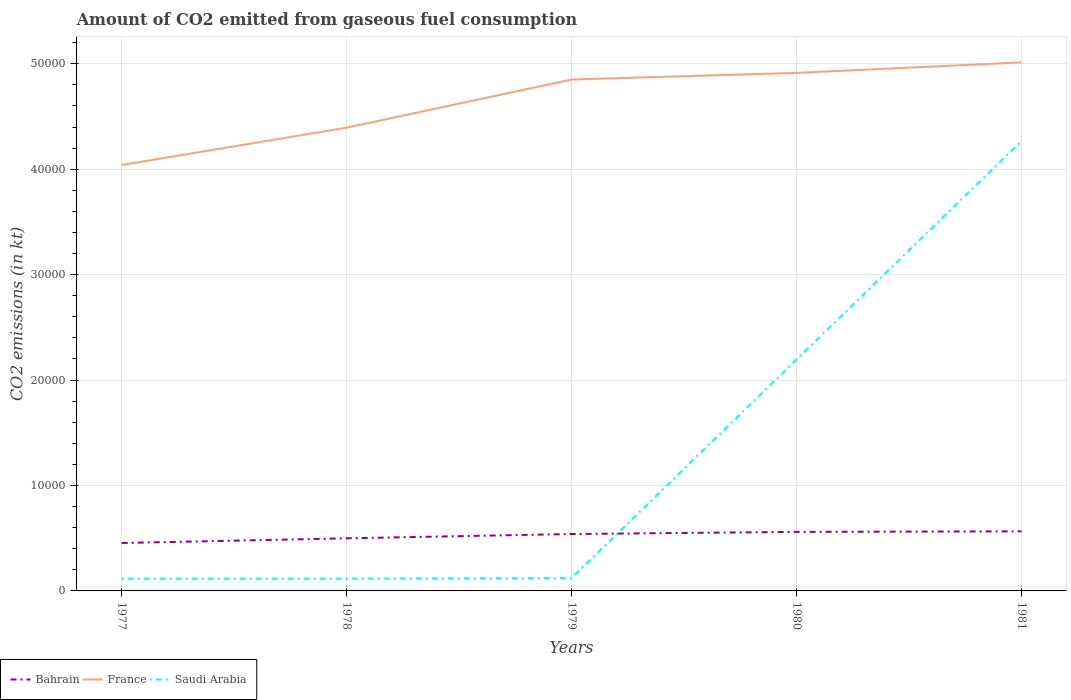How many different coloured lines are there?
Your answer should be compact. 3. Across all years, what is the maximum amount of CO2 emitted in Saudi Arabia?
Your response must be concise. 1162.44. What is the total amount of CO2 emitted in Saudi Arabia in the graph?
Keep it short and to the point. -2.07e+04. What is the difference between the highest and the second highest amount of CO2 emitted in Bahrain?
Your answer should be very brief. 1107.43. What is the difference between the highest and the lowest amount of CO2 emitted in Saudi Arabia?
Your answer should be compact. 2. Is the amount of CO2 emitted in Saudi Arabia strictly greater than the amount of CO2 emitted in France over the years?
Offer a terse response. Yes. How many lines are there?
Ensure brevity in your answer.  3. What is the difference between two consecutive major ticks on the Y-axis?
Keep it short and to the point. 10000. Are the values on the major ticks of Y-axis written in scientific E-notation?
Provide a succinct answer. No. Does the graph contain any zero values?
Offer a terse response. No. What is the title of the graph?
Provide a succinct answer. Amount of CO2 emitted from gaseous fuel consumption. What is the label or title of the X-axis?
Offer a terse response. Years. What is the label or title of the Y-axis?
Ensure brevity in your answer.  CO2 emissions (in kt). What is the CO2 emissions (in kt) in Bahrain in 1977?
Offer a terse response. 4543.41. What is the CO2 emissions (in kt) of France in 1977?
Provide a succinct answer. 4.04e+04. What is the CO2 emissions (in kt) in Saudi Arabia in 1977?
Offer a very short reply. 1162.44. What is the CO2 emissions (in kt) in Bahrain in 1978?
Keep it short and to the point. 4990.79. What is the CO2 emissions (in kt) of France in 1978?
Your answer should be compact. 4.39e+04. What is the CO2 emissions (in kt) of Saudi Arabia in 1978?
Make the answer very short. 1162.44. What is the CO2 emissions (in kt) in Bahrain in 1979?
Make the answer very short. 5397.82. What is the CO2 emissions (in kt) of France in 1979?
Offer a very short reply. 4.85e+04. What is the CO2 emissions (in kt) in Saudi Arabia in 1979?
Your answer should be very brief. 1232.11. What is the CO2 emissions (in kt) of Bahrain in 1980?
Keep it short and to the point. 5599.51. What is the CO2 emissions (in kt) of France in 1980?
Provide a short and direct response. 4.91e+04. What is the CO2 emissions (in kt) in Saudi Arabia in 1980?
Your answer should be compact. 2.20e+04. What is the CO2 emissions (in kt) in Bahrain in 1981?
Provide a succinct answer. 5650.85. What is the CO2 emissions (in kt) in France in 1981?
Provide a short and direct response. 5.01e+04. What is the CO2 emissions (in kt) of Saudi Arabia in 1981?
Provide a short and direct response. 4.27e+04. Across all years, what is the maximum CO2 emissions (in kt) of Bahrain?
Your answer should be compact. 5650.85. Across all years, what is the maximum CO2 emissions (in kt) of France?
Provide a short and direct response. 5.01e+04. Across all years, what is the maximum CO2 emissions (in kt) in Saudi Arabia?
Provide a short and direct response. 4.27e+04. Across all years, what is the minimum CO2 emissions (in kt) of Bahrain?
Offer a very short reply. 4543.41. Across all years, what is the minimum CO2 emissions (in kt) in France?
Your answer should be very brief. 4.04e+04. Across all years, what is the minimum CO2 emissions (in kt) of Saudi Arabia?
Keep it short and to the point. 1162.44. What is the total CO2 emissions (in kt) of Bahrain in the graph?
Make the answer very short. 2.62e+04. What is the total CO2 emissions (in kt) in France in the graph?
Your response must be concise. 2.32e+05. What is the total CO2 emissions (in kt) of Saudi Arabia in the graph?
Ensure brevity in your answer.  6.82e+04. What is the difference between the CO2 emissions (in kt) of Bahrain in 1977 and that in 1978?
Provide a succinct answer. -447.37. What is the difference between the CO2 emissions (in kt) of France in 1977 and that in 1978?
Offer a very short reply. -3545.99. What is the difference between the CO2 emissions (in kt) in Saudi Arabia in 1977 and that in 1978?
Keep it short and to the point. 0. What is the difference between the CO2 emissions (in kt) of Bahrain in 1977 and that in 1979?
Provide a short and direct response. -854.41. What is the difference between the CO2 emissions (in kt) in France in 1977 and that in 1979?
Keep it short and to the point. -8107.74. What is the difference between the CO2 emissions (in kt) of Saudi Arabia in 1977 and that in 1979?
Make the answer very short. -69.67. What is the difference between the CO2 emissions (in kt) in Bahrain in 1977 and that in 1980?
Your response must be concise. -1056.1. What is the difference between the CO2 emissions (in kt) of France in 1977 and that in 1980?
Provide a succinct answer. -8738.46. What is the difference between the CO2 emissions (in kt) of Saudi Arabia in 1977 and that in 1980?
Your response must be concise. -2.08e+04. What is the difference between the CO2 emissions (in kt) in Bahrain in 1977 and that in 1981?
Your answer should be very brief. -1107.43. What is the difference between the CO2 emissions (in kt) in France in 1977 and that in 1981?
Provide a short and direct response. -9732.22. What is the difference between the CO2 emissions (in kt) in Saudi Arabia in 1977 and that in 1981?
Offer a very short reply. -4.15e+04. What is the difference between the CO2 emissions (in kt) of Bahrain in 1978 and that in 1979?
Your answer should be compact. -407.04. What is the difference between the CO2 emissions (in kt) in France in 1978 and that in 1979?
Provide a succinct answer. -4561.75. What is the difference between the CO2 emissions (in kt) of Saudi Arabia in 1978 and that in 1979?
Make the answer very short. -69.67. What is the difference between the CO2 emissions (in kt) in Bahrain in 1978 and that in 1980?
Offer a terse response. -608.72. What is the difference between the CO2 emissions (in kt) in France in 1978 and that in 1980?
Your response must be concise. -5192.47. What is the difference between the CO2 emissions (in kt) in Saudi Arabia in 1978 and that in 1980?
Offer a very short reply. -2.08e+04. What is the difference between the CO2 emissions (in kt) in Bahrain in 1978 and that in 1981?
Ensure brevity in your answer.  -660.06. What is the difference between the CO2 emissions (in kt) in France in 1978 and that in 1981?
Make the answer very short. -6186.23. What is the difference between the CO2 emissions (in kt) in Saudi Arabia in 1978 and that in 1981?
Give a very brief answer. -4.15e+04. What is the difference between the CO2 emissions (in kt) of Bahrain in 1979 and that in 1980?
Ensure brevity in your answer.  -201.69. What is the difference between the CO2 emissions (in kt) in France in 1979 and that in 1980?
Provide a succinct answer. -630.72. What is the difference between the CO2 emissions (in kt) of Saudi Arabia in 1979 and that in 1980?
Give a very brief answer. -2.07e+04. What is the difference between the CO2 emissions (in kt) of Bahrain in 1979 and that in 1981?
Provide a short and direct response. -253.02. What is the difference between the CO2 emissions (in kt) in France in 1979 and that in 1981?
Make the answer very short. -1624.48. What is the difference between the CO2 emissions (in kt) of Saudi Arabia in 1979 and that in 1981?
Give a very brief answer. -4.15e+04. What is the difference between the CO2 emissions (in kt) of Bahrain in 1980 and that in 1981?
Your response must be concise. -51.34. What is the difference between the CO2 emissions (in kt) of France in 1980 and that in 1981?
Keep it short and to the point. -993.76. What is the difference between the CO2 emissions (in kt) in Saudi Arabia in 1980 and that in 1981?
Offer a terse response. -2.07e+04. What is the difference between the CO2 emissions (in kt) in Bahrain in 1977 and the CO2 emissions (in kt) in France in 1978?
Keep it short and to the point. -3.94e+04. What is the difference between the CO2 emissions (in kt) of Bahrain in 1977 and the CO2 emissions (in kt) of Saudi Arabia in 1978?
Provide a short and direct response. 3380.97. What is the difference between the CO2 emissions (in kt) in France in 1977 and the CO2 emissions (in kt) in Saudi Arabia in 1978?
Provide a succinct answer. 3.92e+04. What is the difference between the CO2 emissions (in kt) of Bahrain in 1977 and the CO2 emissions (in kt) of France in 1979?
Offer a very short reply. -4.40e+04. What is the difference between the CO2 emissions (in kt) in Bahrain in 1977 and the CO2 emissions (in kt) in Saudi Arabia in 1979?
Offer a very short reply. 3311.3. What is the difference between the CO2 emissions (in kt) in France in 1977 and the CO2 emissions (in kt) in Saudi Arabia in 1979?
Your answer should be compact. 3.92e+04. What is the difference between the CO2 emissions (in kt) in Bahrain in 1977 and the CO2 emissions (in kt) in France in 1980?
Ensure brevity in your answer.  -4.46e+04. What is the difference between the CO2 emissions (in kt) of Bahrain in 1977 and the CO2 emissions (in kt) of Saudi Arabia in 1980?
Your answer should be compact. -1.74e+04. What is the difference between the CO2 emissions (in kt) of France in 1977 and the CO2 emissions (in kt) of Saudi Arabia in 1980?
Offer a terse response. 1.84e+04. What is the difference between the CO2 emissions (in kt) of Bahrain in 1977 and the CO2 emissions (in kt) of France in 1981?
Make the answer very short. -4.56e+04. What is the difference between the CO2 emissions (in kt) of Bahrain in 1977 and the CO2 emissions (in kt) of Saudi Arabia in 1981?
Offer a terse response. -3.81e+04. What is the difference between the CO2 emissions (in kt) of France in 1977 and the CO2 emissions (in kt) of Saudi Arabia in 1981?
Provide a succinct answer. -2284.54. What is the difference between the CO2 emissions (in kt) of Bahrain in 1978 and the CO2 emissions (in kt) of France in 1979?
Offer a terse response. -4.35e+04. What is the difference between the CO2 emissions (in kt) of Bahrain in 1978 and the CO2 emissions (in kt) of Saudi Arabia in 1979?
Your answer should be very brief. 3758.68. What is the difference between the CO2 emissions (in kt) in France in 1978 and the CO2 emissions (in kt) in Saudi Arabia in 1979?
Your answer should be very brief. 4.27e+04. What is the difference between the CO2 emissions (in kt) of Bahrain in 1978 and the CO2 emissions (in kt) of France in 1980?
Your response must be concise. -4.41e+04. What is the difference between the CO2 emissions (in kt) of Bahrain in 1978 and the CO2 emissions (in kt) of Saudi Arabia in 1980?
Give a very brief answer. -1.70e+04. What is the difference between the CO2 emissions (in kt) of France in 1978 and the CO2 emissions (in kt) of Saudi Arabia in 1980?
Offer a terse response. 2.20e+04. What is the difference between the CO2 emissions (in kt) in Bahrain in 1978 and the CO2 emissions (in kt) in France in 1981?
Make the answer very short. -4.51e+04. What is the difference between the CO2 emissions (in kt) of Bahrain in 1978 and the CO2 emissions (in kt) of Saudi Arabia in 1981?
Offer a terse response. -3.77e+04. What is the difference between the CO2 emissions (in kt) of France in 1978 and the CO2 emissions (in kt) of Saudi Arabia in 1981?
Keep it short and to the point. 1261.45. What is the difference between the CO2 emissions (in kt) in Bahrain in 1979 and the CO2 emissions (in kt) in France in 1980?
Provide a succinct answer. -4.37e+04. What is the difference between the CO2 emissions (in kt) in Bahrain in 1979 and the CO2 emissions (in kt) in Saudi Arabia in 1980?
Your response must be concise. -1.66e+04. What is the difference between the CO2 emissions (in kt) in France in 1979 and the CO2 emissions (in kt) in Saudi Arabia in 1980?
Keep it short and to the point. 2.65e+04. What is the difference between the CO2 emissions (in kt) of Bahrain in 1979 and the CO2 emissions (in kt) of France in 1981?
Your answer should be very brief. -4.47e+04. What is the difference between the CO2 emissions (in kt) of Bahrain in 1979 and the CO2 emissions (in kt) of Saudi Arabia in 1981?
Keep it short and to the point. -3.73e+04. What is the difference between the CO2 emissions (in kt) in France in 1979 and the CO2 emissions (in kt) in Saudi Arabia in 1981?
Offer a very short reply. 5823.2. What is the difference between the CO2 emissions (in kt) in Bahrain in 1980 and the CO2 emissions (in kt) in France in 1981?
Ensure brevity in your answer.  -4.45e+04. What is the difference between the CO2 emissions (in kt) in Bahrain in 1980 and the CO2 emissions (in kt) in Saudi Arabia in 1981?
Provide a short and direct response. -3.71e+04. What is the difference between the CO2 emissions (in kt) in France in 1980 and the CO2 emissions (in kt) in Saudi Arabia in 1981?
Ensure brevity in your answer.  6453.92. What is the average CO2 emissions (in kt) of Bahrain per year?
Your answer should be very brief. 5236.48. What is the average CO2 emissions (in kt) of France per year?
Keep it short and to the point. 4.64e+04. What is the average CO2 emissions (in kt) in Saudi Arabia per year?
Keep it short and to the point. 1.36e+04. In the year 1977, what is the difference between the CO2 emissions (in kt) of Bahrain and CO2 emissions (in kt) of France?
Provide a short and direct response. -3.59e+04. In the year 1977, what is the difference between the CO2 emissions (in kt) of Bahrain and CO2 emissions (in kt) of Saudi Arabia?
Offer a very short reply. 3380.97. In the year 1977, what is the difference between the CO2 emissions (in kt) in France and CO2 emissions (in kt) in Saudi Arabia?
Your answer should be very brief. 3.92e+04. In the year 1978, what is the difference between the CO2 emissions (in kt) in Bahrain and CO2 emissions (in kt) in France?
Keep it short and to the point. -3.90e+04. In the year 1978, what is the difference between the CO2 emissions (in kt) in Bahrain and CO2 emissions (in kt) in Saudi Arabia?
Your answer should be very brief. 3828.35. In the year 1978, what is the difference between the CO2 emissions (in kt) in France and CO2 emissions (in kt) in Saudi Arabia?
Your answer should be very brief. 4.28e+04. In the year 1979, what is the difference between the CO2 emissions (in kt) of Bahrain and CO2 emissions (in kt) of France?
Your answer should be compact. -4.31e+04. In the year 1979, what is the difference between the CO2 emissions (in kt) of Bahrain and CO2 emissions (in kt) of Saudi Arabia?
Provide a short and direct response. 4165.71. In the year 1979, what is the difference between the CO2 emissions (in kt) in France and CO2 emissions (in kt) in Saudi Arabia?
Your response must be concise. 4.73e+04. In the year 1980, what is the difference between the CO2 emissions (in kt) of Bahrain and CO2 emissions (in kt) of France?
Give a very brief answer. -4.35e+04. In the year 1980, what is the difference between the CO2 emissions (in kt) of Bahrain and CO2 emissions (in kt) of Saudi Arabia?
Keep it short and to the point. -1.64e+04. In the year 1980, what is the difference between the CO2 emissions (in kt) in France and CO2 emissions (in kt) in Saudi Arabia?
Keep it short and to the point. 2.72e+04. In the year 1981, what is the difference between the CO2 emissions (in kt) in Bahrain and CO2 emissions (in kt) in France?
Ensure brevity in your answer.  -4.45e+04. In the year 1981, what is the difference between the CO2 emissions (in kt) of Bahrain and CO2 emissions (in kt) of Saudi Arabia?
Your answer should be very brief. -3.70e+04. In the year 1981, what is the difference between the CO2 emissions (in kt) of France and CO2 emissions (in kt) of Saudi Arabia?
Give a very brief answer. 7447.68. What is the ratio of the CO2 emissions (in kt) of Bahrain in 1977 to that in 1978?
Your answer should be compact. 0.91. What is the ratio of the CO2 emissions (in kt) of France in 1977 to that in 1978?
Ensure brevity in your answer.  0.92. What is the ratio of the CO2 emissions (in kt) in Saudi Arabia in 1977 to that in 1978?
Your answer should be very brief. 1. What is the ratio of the CO2 emissions (in kt) of Bahrain in 1977 to that in 1979?
Keep it short and to the point. 0.84. What is the ratio of the CO2 emissions (in kt) of France in 1977 to that in 1979?
Your response must be concise. 0.83. What is the ratio of the CO2 emissions (in kt) in Saudi Arabia in 1977 to that in 1979?
Give a very brief answer. 0.94. What is the ratio of the CO2 emissions (in kt) in Bahrain in 1977 to that in 1980?
Your answer should be very brief. 0.81. What is the ratio of the CO2 emissions (in kt) of France in 1977 to that in 1980?
Give a very brief answer. 0.82. What is the ratio of the CO2 emissions (in kt) of Saudi Arabia in 1977 to that in 1980?
Offer a terse response. 0.05. What is the ratio of the CO2 emissions (in kt) in Bahrain in 1977 to that in 1981?
Provide a succinct answer. 0.8. What is the ratio of the CO2 emissions (in kt) of France in 1977 to that in 1981?
Offer a very short reply. 0.81. What is the ratio of the CO2 emissions (in kt) of Saudi Arabia in 1977 to that in 1981?
Your answer should be compact. 0.03. What is the ratio of the CO2 emissions (in kt) in Bahrain in 1978 to that in 1979?
Make the answer very short. 0.92. What is the ratio of the CO2 emissions (in kt) in France in 1978 to that in 1979?
Offer a terse response. 0.91. What is the ratio of the CO2 emissions (in kt) in Saudi Arabia in 1978 to that in 1979?
Keep it short and to the point. 0.94. What is the ratio of the CO2 emissions (in kt) in Bahrain in 1978 to that in 1980?
Give a very brief answer. 0.89. What is the ratio of the CO2 emissions (in kt) in France in 1978 to that in 1980?
Offer a terse response. 0.89. What is the ratio of the CO2 emissions (in kt) of Saudi Arabia in 1978 to that in 1980?
Provide a succinct answer. 0.05. What is the ratio of the CO2 emissions (in kt) in Bahrain in 1978 to that in 1981?
Keep it short and to the point. 0.88. What is the ratio of the CO2 emissions (in kt) of France in 1978 to that in 1981?
Keep it short and to the point. 0.88. What is the ratio of the CO2 emissions (in kt) of Saudi Arabia in 1978 to that in 1981?
Provide a short and direct response. 0.03. What is the ratio of the CO2 emissions (in kt) of France in 1979 to that in 1980?
Keep it short and to the point. 0.99. What is the ratio of the CO2 emissions (in kt) of Saudi Arabia in 1979 to that in 1980?
Offer a very short reply. 0.06. What is the ratio of the CO2 emissions (in kt) of Bahrain in 1979 to that in 1981?
Offer a very short reply. 0.96. What is the ratio of the CO2 emissions (in kt) in France in 1979 to that in 1981?
Make the answer very short. 0.97. What is the ratio of the CO2 emissions (in kt) in Saudi Arabia in 1979 to that in 1981?
Offer a terse response. 0.03. What is the ratio of the CO2 emissions (in kt) of Bahrain in 1980 to that in 1981?
Provide a succinct answer. 0.99. What is the ratio of the CO2 emissions (in kt) of France in 1980 to that in 1981?
Offer a very short reply. 0.98. What is the ratio of the CO2 emissions (in kt) of Saudi Arabia in 1980 to that in 1981?
Provide a succinct answer. 0.51. What is the difference between the highest and the second highest CO2 emissions (in kt) in Bahrain?
Make the answer very short. 51.34. What is the difference between the highest and the second highest CO2 emissions (in kt) of France?
Your response must be concise. 993.76. What is the difference between the highest and the second highest CO2 emissions (in kt) in Saudi Arabia?
Keep it short and to the point. 2.07e+04. What is the difference between the highest and the lowest CO2 emissions (in kt) in Bahrain?
Provide a short and direct response. 1107.43. What is the difference between the highest and the lowest CO2 emissions (in kt) in France?
Give a very brief answer. 9732.22. What is the difference between the highest and the lowest CO2 emissions (in kt) in Saudi Arabia?
Offer a very short reply. 4.15e+04. 